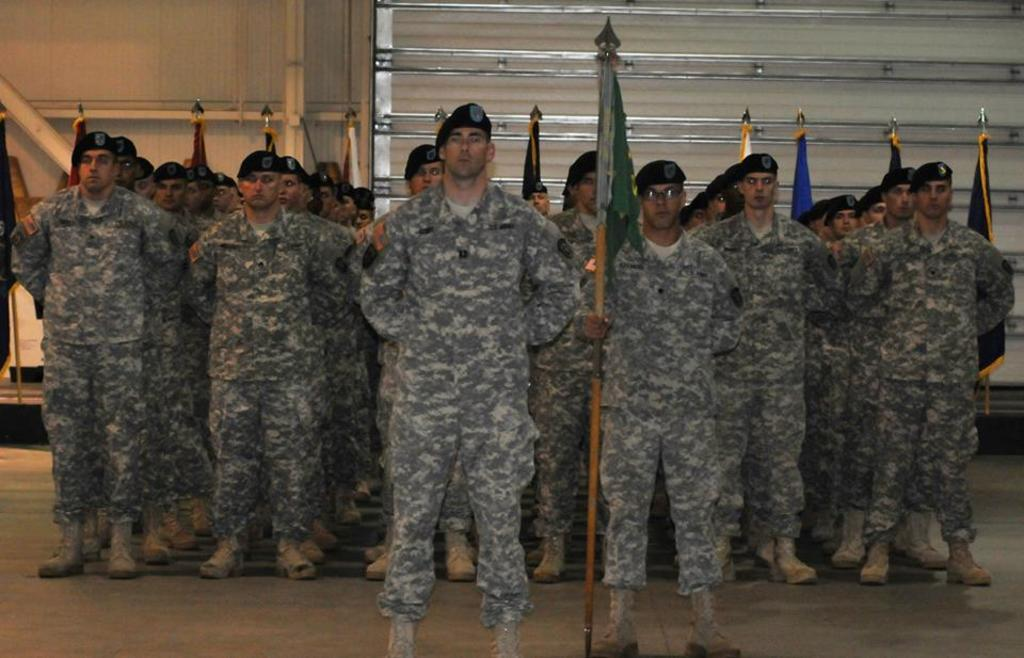What is there are people in the image, what are they doing? There are people standing on a floor in the image, and they are holding flags in their hands. What can be seen in the background of the image? There is a wall in the background of the image. How many letters are visible on the yak in the image? There is no yak present in the image, and therefore no letters can be seen on it. 